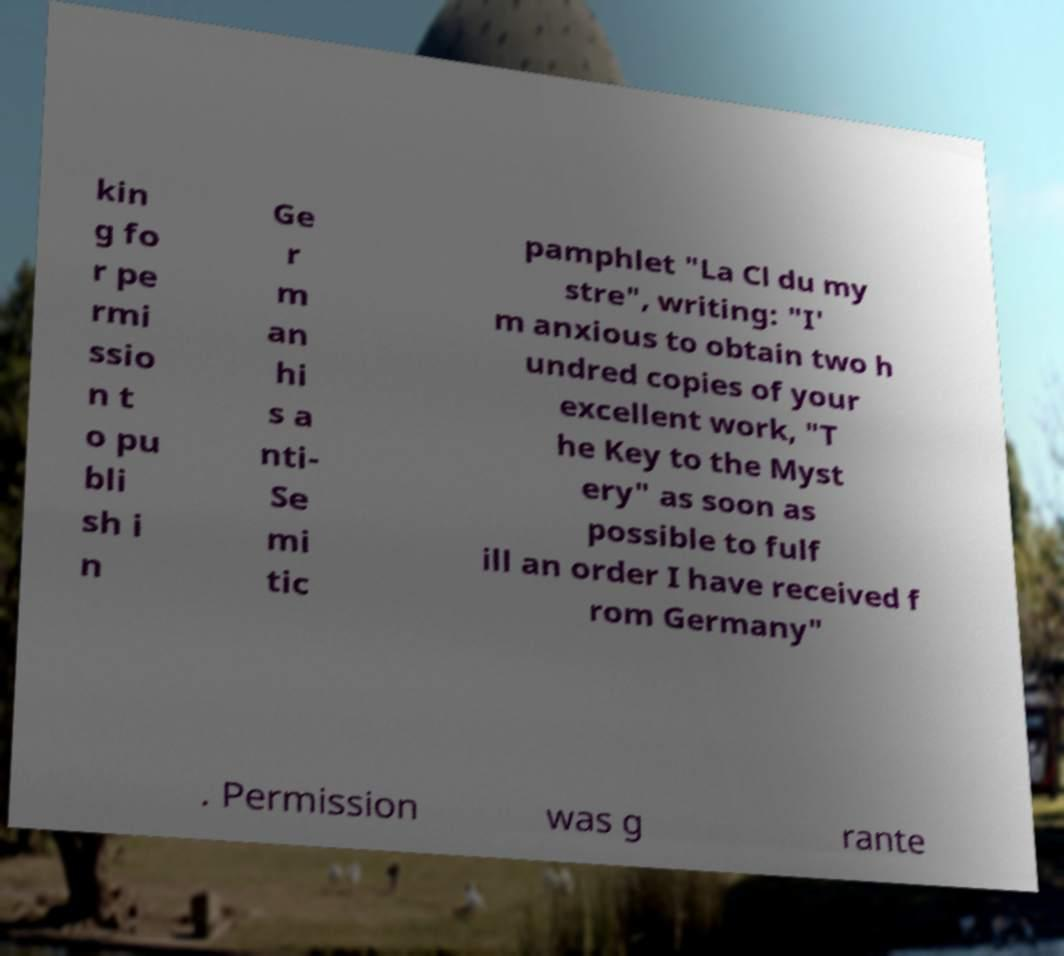Could you assist in decoding the text presented in this image and type it out clearly? kin g fo r pe rmi ssio n t o pu bli sh i n Ge r m an hi s a nti- Se mi tic pamphlet "La Cl du my stre", writing: "I' m anxious to obtain two h undred copies of your excellent work, "T he Key to the Myst ery" as soon as possible to fulf ill an order I have received f rom Germany" . Permission was g rante 